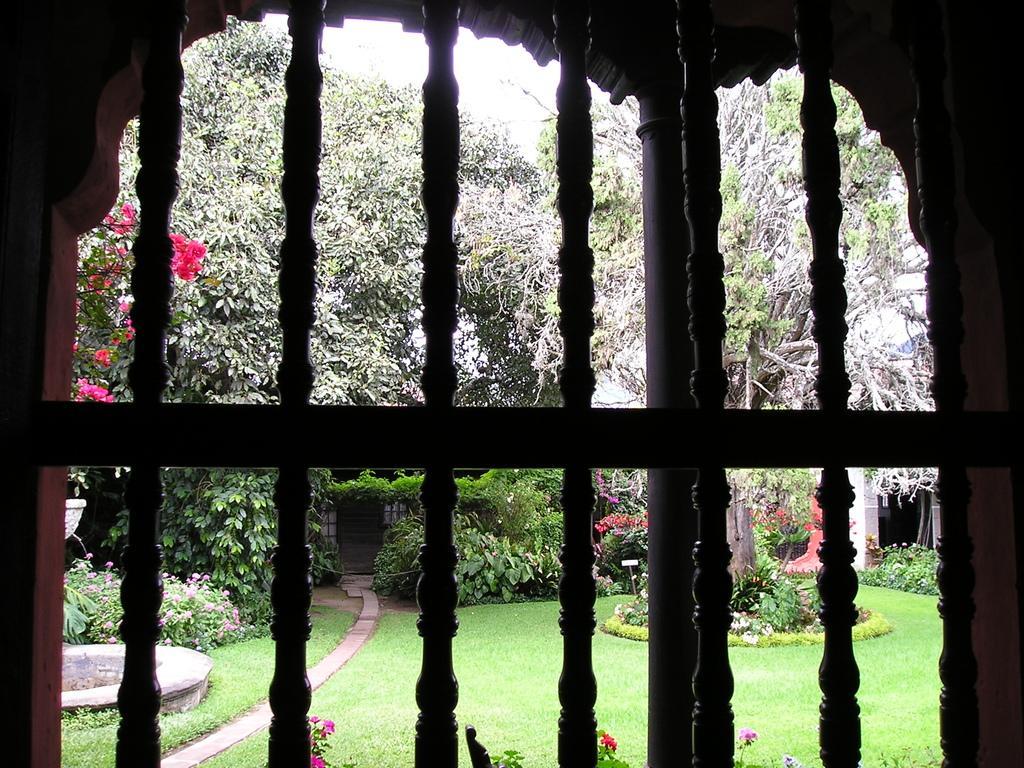Can you describe this image briefly? This image consists of a window through which we can see many trees and green grass. At the bottom, there are flowers. 